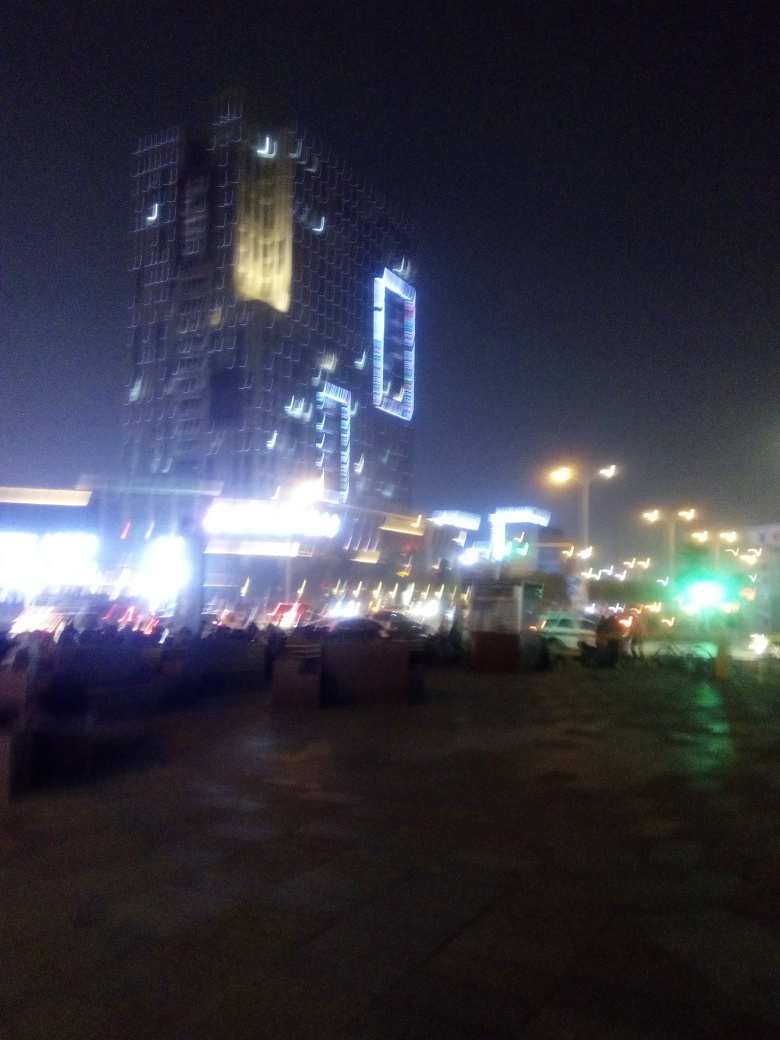Can you describe the atmosphere of this location? Despite the blur, the image evokes a bustling urban atmosphere, possibly a lively district or city center at night. The lights suggest vibrancy and ongoing activity, potentially with people going about their nightly routines or enjoying nightlife. 